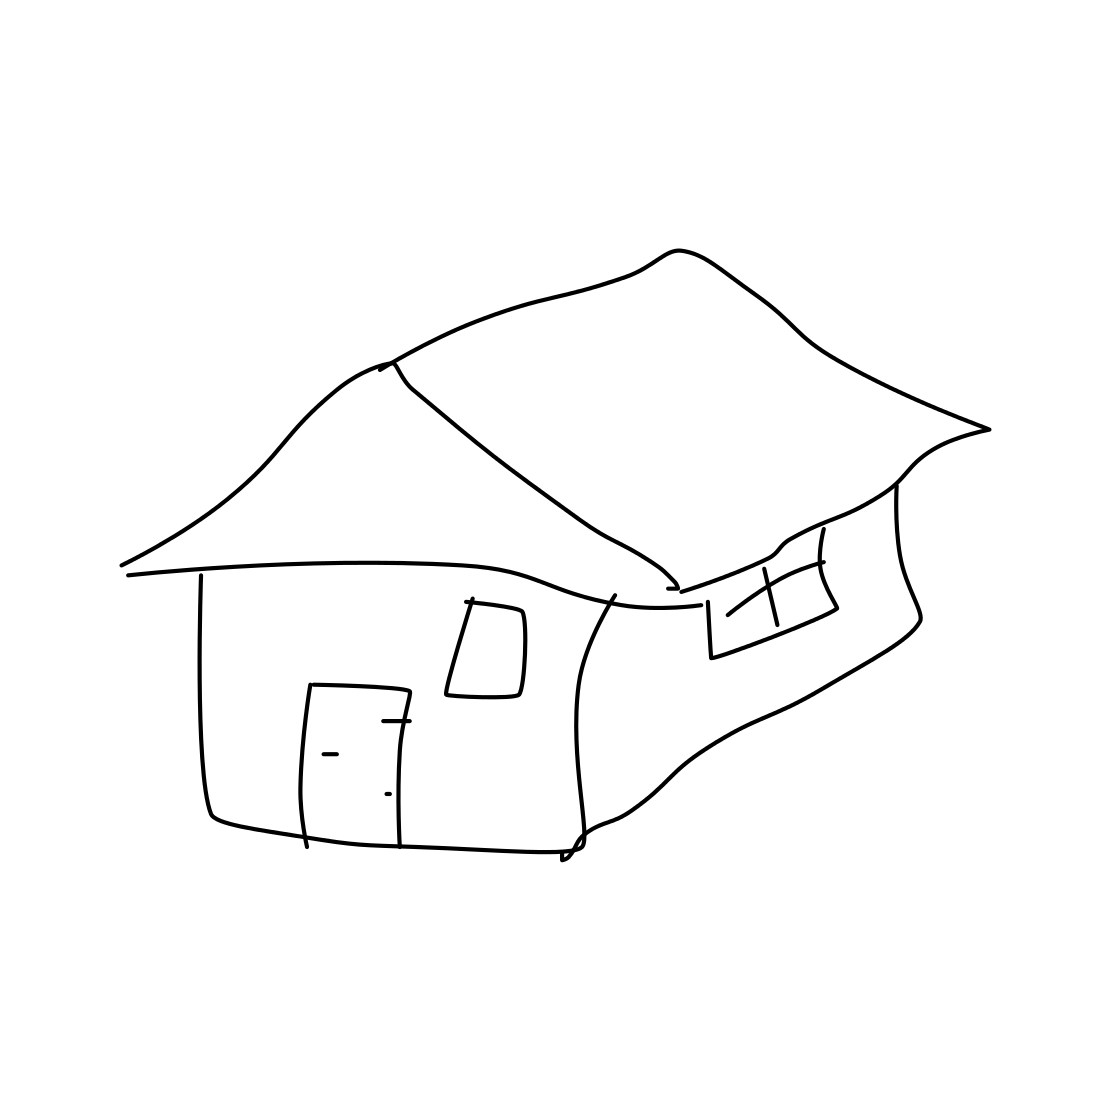Is there a sketchy house in the picture? Yes, the image contains a rudimentary sketch of a house, characterized by simple lines and shapes that represent the structure's basic features such as the roof, walls, windows, and door. 